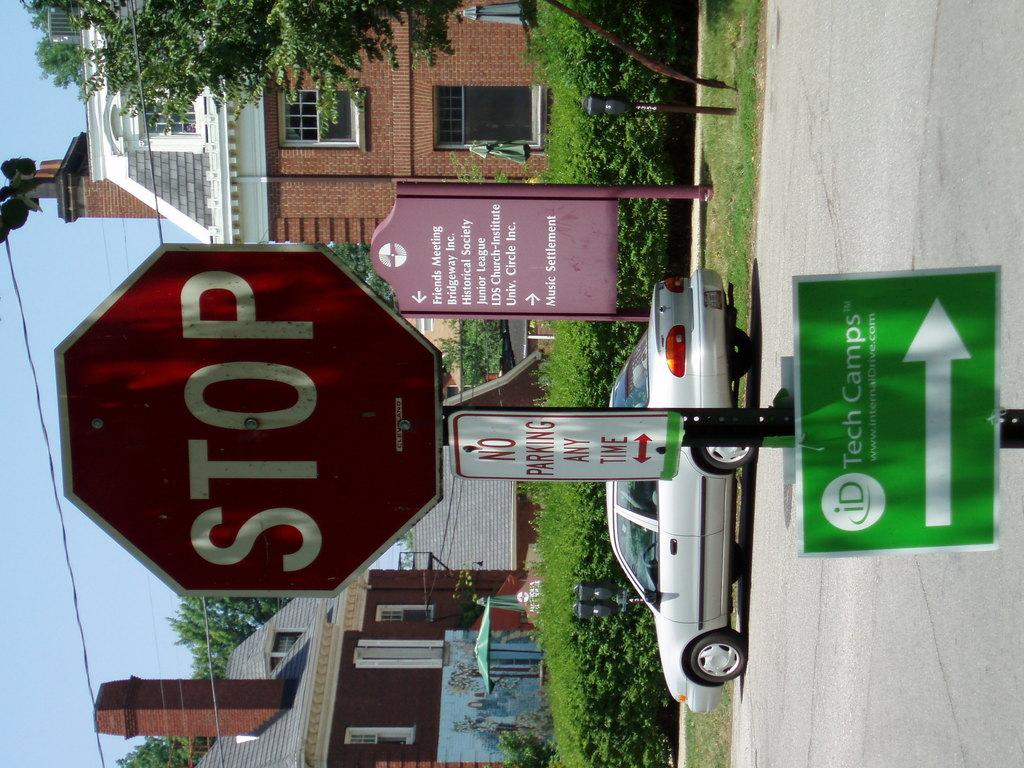<image>
Give a short and clear explanation of the subsequent image. A stop sign is above a No Parking Any Time sign with a brick building behind it. 